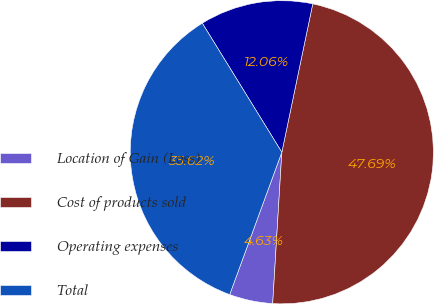Convert chart to OTSL. <chart><loc_0><loc_0><loc_500><loc_500><pie_chart><fcel>Location of Gain (Loss)<fcel>Cost of products sold<fcel>Operating expenses<fcel>Total<nl><fcel>4.63%<fcel>47.69%<fcel>12.06%<fcel>35.62%<nl></chart> 